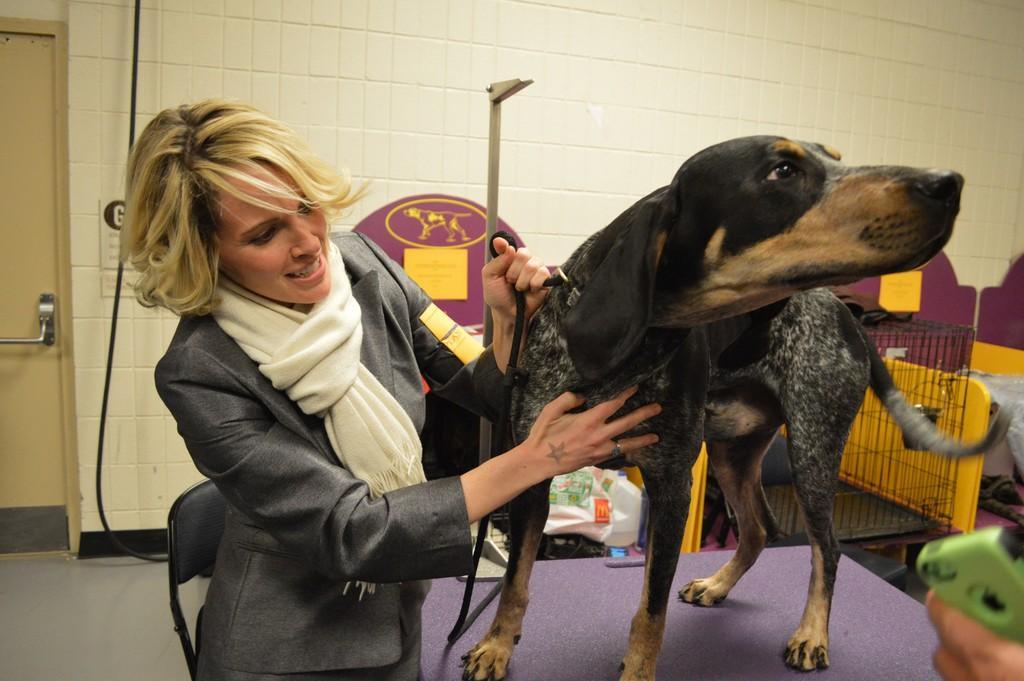Can you describe this image briefly? This is the picture of inside the room. There is a person standing and holding the dog. There is a dog on the table. At the left side of the image there is a door. 